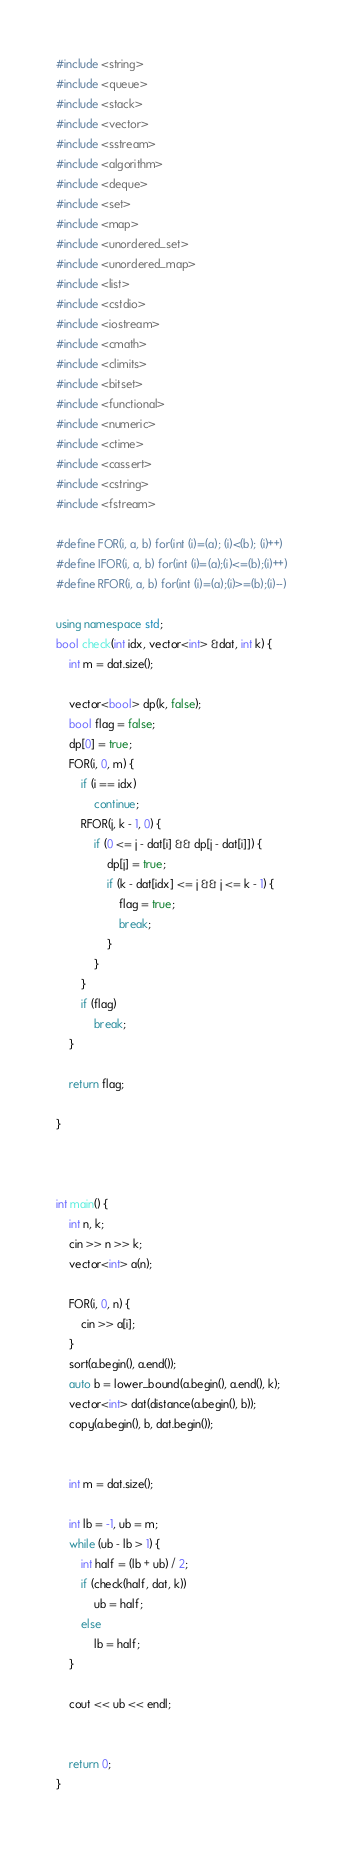Convert code to text. <code><loc_0><loc_0><loc_500><loc_500><_C++_>#include <string>
#include <queue>
#include <stack>
#include <vector>
#include <sstream>
#include <algorithm>
#include <deque>
#include <set>
#include <map>
#include <unordered_set>
#include <unordered_map>
#include <list>
#include <cstdio>
#include <iostream>
#include <cmath>
#include <climits>
#include <bitset>
#include <functional>
#include <numeric>
#include <ctime>
#include <cassert>
#include <cstring>
#include <fstream>

#define FOR(i, a, b) for(int (i)=(a); (i)<(b); (i)++)
#define IFOR(i, a, b) for(int (i)=(a);(i)<=(b);(i)++)
#define RFOR(i, a, b) for(int (i)=(a);(i)>=(b);(i)--)

using namespace std;
bool check(int idx, vector<int> &dat, int k) {
    int m = dat.size();

    vector<bool> dp(k, false);
    bool flag = false;
    dp[0] = true;
    FOR(i, 0, m) {
        if (i == idx)
            continue;
        RFOR(j, k - 1, 0) {
            if (0 <= j - dat[i] && dp[j - dat[i]]) {
                dp[j] = true;
                if (k - dat[idx] <= j && j <= k - 1) {
                    flag = true;
                    break;
                }
            }
        }
        if (flag)
            break;
    }

    return flag;

}



int main() {
    int n, k;
    cin >> n >> k;
    vector<int> a(n);

    FOR(i, 0, n) {
        cin >> a[i];
    }
    sort(a.begin(), a.end());
    auto b = lower_bound(a.begin(), a.end(), k);
    vector<int> dat(distance(a.begin(), b));
    copy(a.begin(), b, dat.begin());


    int m = dat.size();

    int lb = -1, ub = m;
    while (ub - lb > 1) {
        int half = (lb + ub) / 2;
        if (check(half, dat, k))
            ub = half;
        else
            lb = half;
    }

    cout << ub << endl;


    return 0;
}</code> 